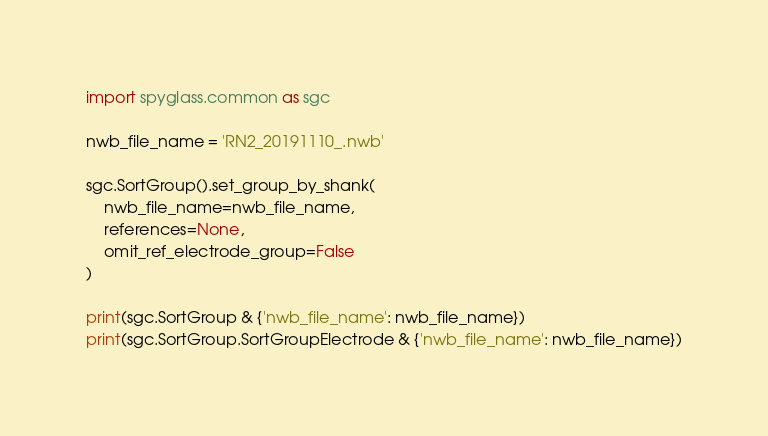Convert code to text. <code><loc_0><loc_0><loc_500><loc_500><_Python_>import spyglass.common as sgc

nwb_file_name = 'RN2_20191110_.nwb'

sgc.SortGroup().set_group_by_shank(
    nwb_file_name=nwb_file_name,
    references=None,
    omit_ref_electrode_group=False
)

print(sgc.SortGroup & {'nwb_file_name': nwb_file_name})
print(sgc.SortGroup.SortGroupElectrode & {'nwb_file_name': nwb_file_name})</code> 